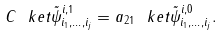<formula> <loc_0><loc_0><loc_500><loc_500>C \ k e t { \tilde { \psi } ^ { i , 1 } _ { i _ { 1 } , \dots , i _ { j } } } = a _ { 2 1 } \ k e t { \tilde { \psi } ^ { i , 0 } _ { i _ { 1 } , \dots , i _ { j } } } .</formula> 